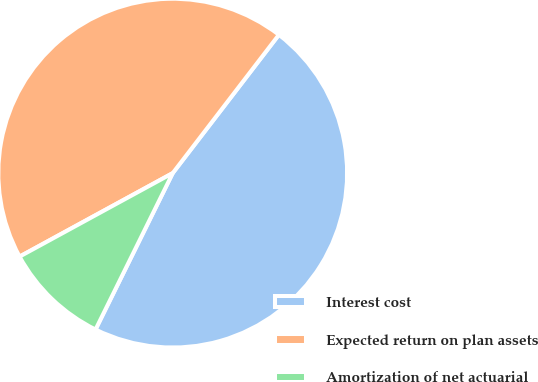Convert chart. <chart><loc_0><loc_0><loc_500><loc_500><pie_chart><fcel>Interest cost<fcel>Expected return on plan assets<fcel>Amortization of net actuarial<nl><fcel>46.88%<fcel>43.36%<fcel>9.76%<nl></chart> 